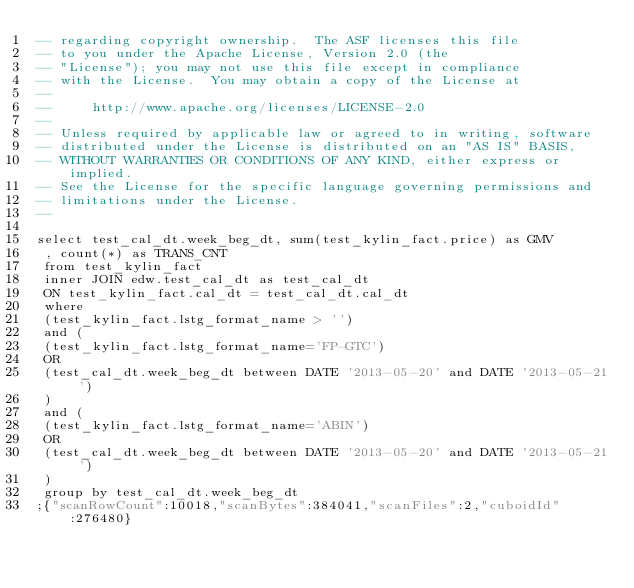Convert code to text. <code><loc_0><loc_0><loc_500><loc_500><_SQL_>-- regarding copyright ownership.  The ASF licenses this file
-- to you under the Apache License, Version 2.0 (the
-- "License"); you may not use this file except in compliance
-- with the License.  You may obtain a copy of the License at
--
--     http://www.apache.org/licenses/LICENSE-2.0
--
-- Unless required by applicable law or agreed to in writing, software
-- distributed under the License is distributed on an "AS IS" BASIS,
-- WITHOUT WARRANTIES OR CONDITIONS OF ANY KIND, either express or implied.
-- See the License for the specific language governing permissions and
-- limitations under the License.
--

select test_cal_dt.week_beg_dt, sum(test_kylin_fact.price) as GMV 
 , count(*) as TRANS_CNT 
 from test_kylin_fact 
 inner JOIN edw.test_cal_dt as test_cal_dt 
 ON test_kylin_fact.cal_dt = test_cal_dt.cal_dt 
 where 
 (test_kylin_fact.lstg_format_name > '') 
 and ( 
 (test_kylin_fact.lstg_format_name='FP-GTC') 
 OR 
 (test_cal_dt.week_beg_dt between DATE '2013-05-20' and DATE '2013-05-21') 
 ) 
 and ( 
 (test_kylin_fact.lstg_format_name='ABIN') 
 OR 
 (test_cal_dt.week_beg_dt between DATE '2013-05-20' and DATE '2013-05-21') 
 ) 
 group by test_cal_dt.week_beg_dt
;{"scanRowCount":10018,"scanBytes":384041,"scanFiles":2,"cuboidId":276480}</code> 